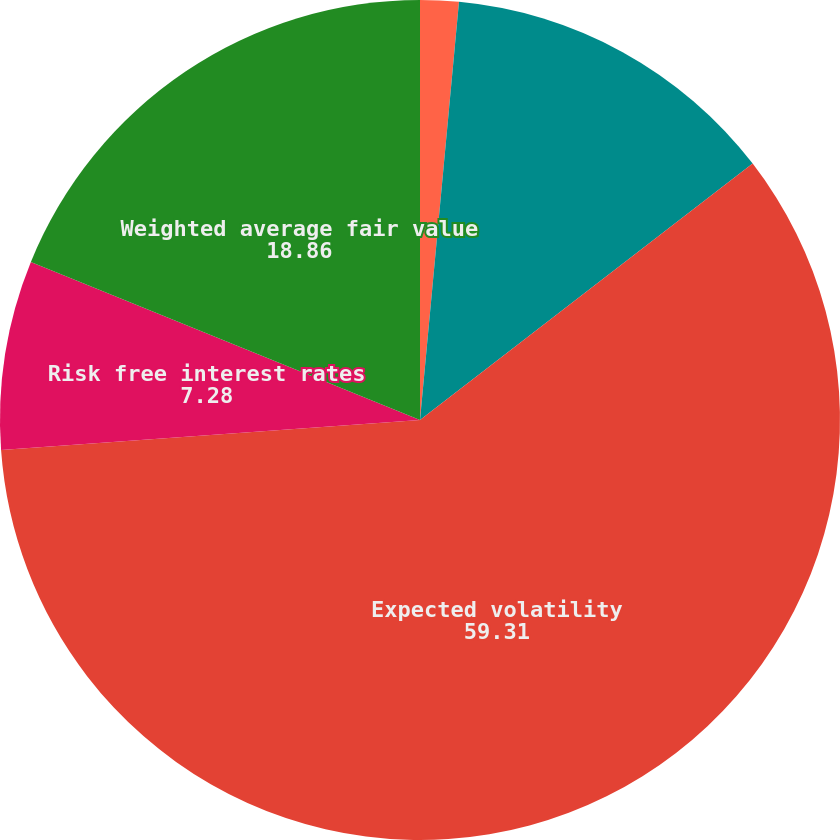<chart> <loc_0><loc_0><loc_500><loc_500><pie_chart><fcel>Dividend<fcel>Dividend yield<fcel>Expected volatility<fcel>Risk free interest rates<fcel>Weighted average fair value<nl><fcel>1.48%<fcel>13.07%<fcel>59.31%<fcel>7.28%<fcel>18.86%<nl></chart> 